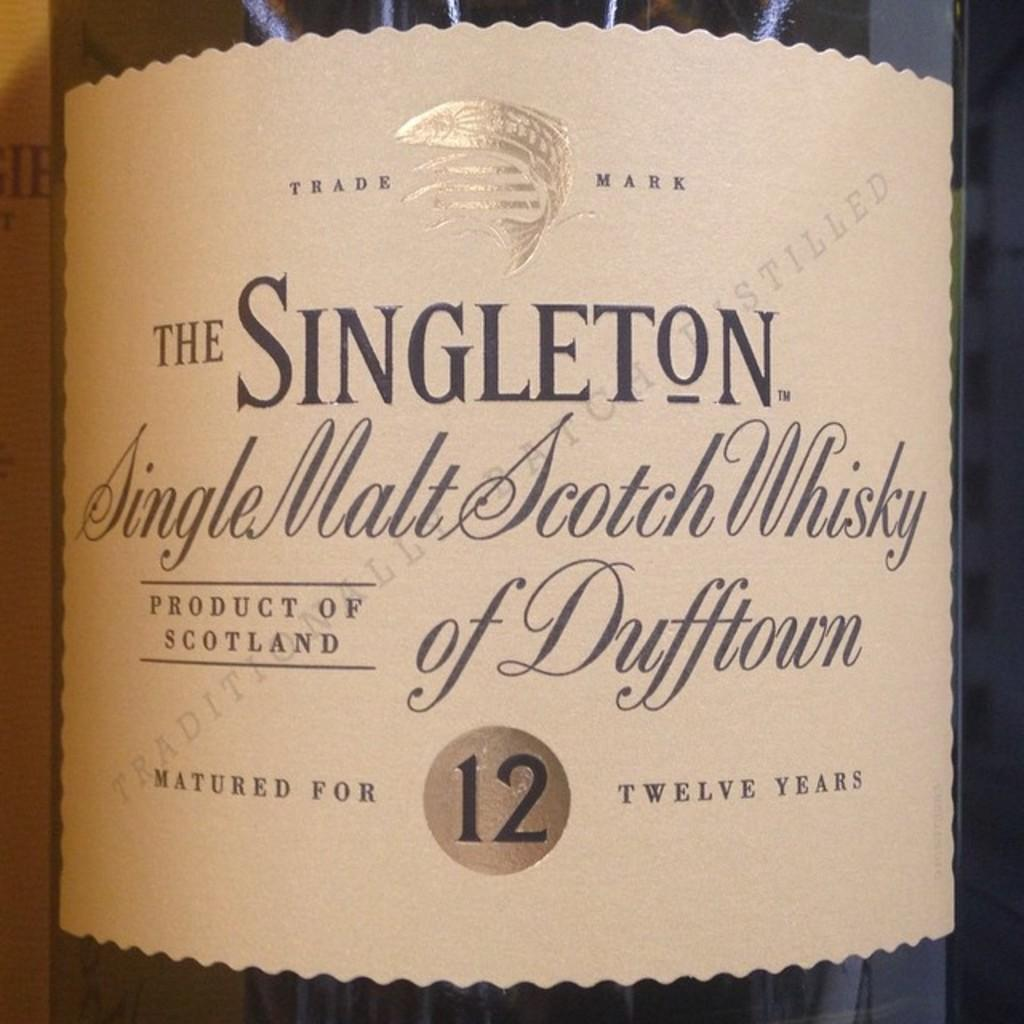<image>
Describe the image concisely. Bottle of Single Malt Scotch Whisky of Dufftown matured for 12 years. 